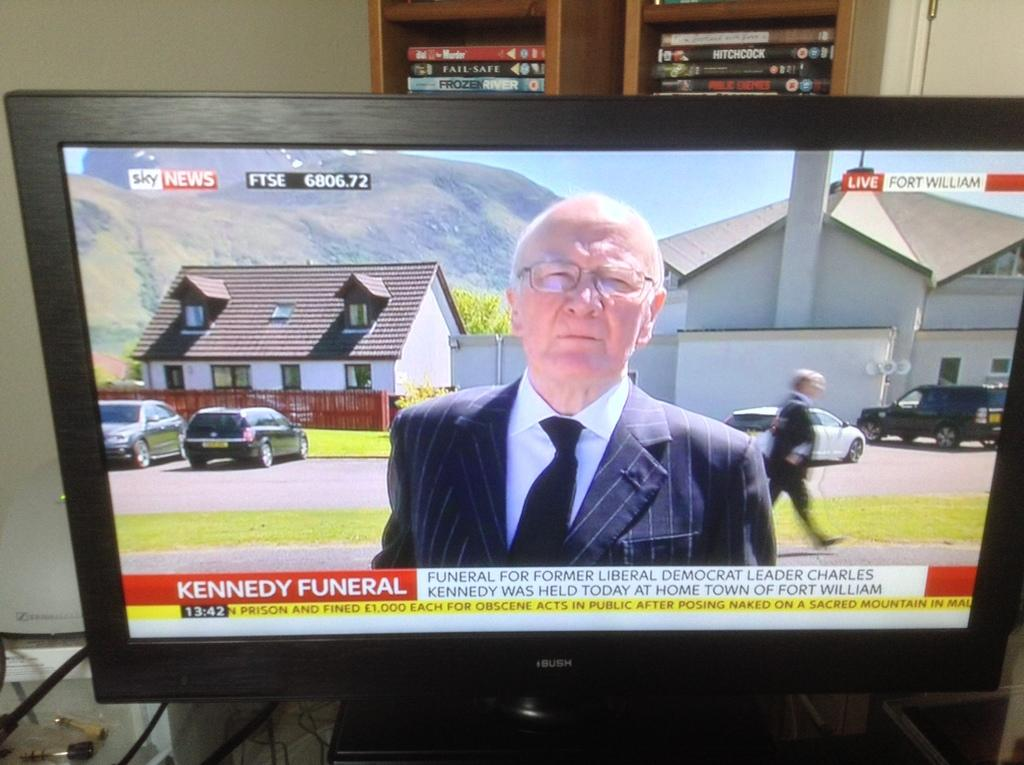<image>
Create a compact narrative representing the image presented. A black TV showing the news of Charles Kennedy's funeral. 